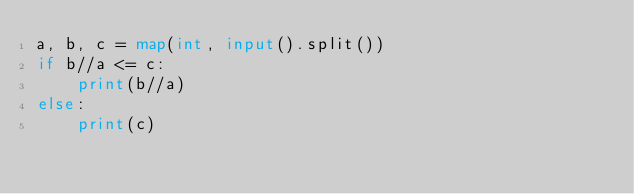Convert code to text. <code><loc_0><loc_0><loc_500><loc_500><_Python_>a, b, c = map(int, input().split())
if b//a <= c:
    print(b//a)
else:
    print(c)</code> 